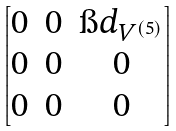Convert formula to latex. <formula><loc_0><loc_0><loc_500><loc_500>\begin{bmatrix} 0 & 0 & \i d _ { V ^ { ( 5 ) } } \\ 0 & 0 & 0 \\ 0 & 0 & 0 \end{bmatrix}</formula> 